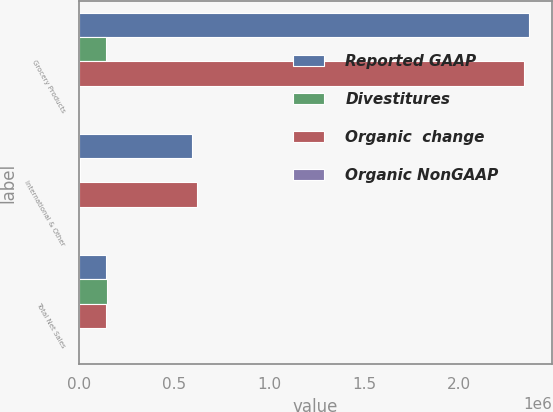Convert chart to OTSL. <chart><loc_0><loc_0><loc_500><loc_500><stacked_bar_chart><ecel><fcel>Grocery Products<fcel>International & Other<fcel>Total Net Sales<nl><fcel>Reported GAAP<fcel>2.36932e+06<fcel>593476<fcel>143749<nl><fcel>Divestitures<fcel>141401<fcel>4696<fcel>146097<nl><fcel>Organic  change<fcel>2.33897e+06<fcel>619743<fcel>143749<nl><fcel>Organic NonGAAP<fcel>1.3<fcel>4.2<fcel>1<nl></chart> 